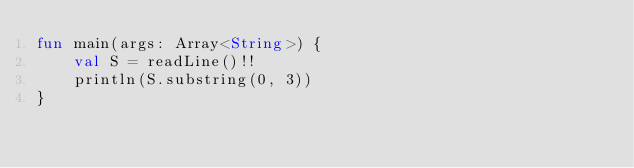Convert code to text. <code><loc_0><loc_0><loc_500><loc_500><_Kotlin_>fun main(args: Array<String>) {
    val S = readLine()!!
    println(S.substring(0, 3))
}</code> 